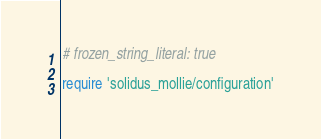<code> <loc_0><loc_0><loc_500><loc_500><_Ruby_># frozen_string_literal: true

require 'solidus_mollie/configuration'</code> 